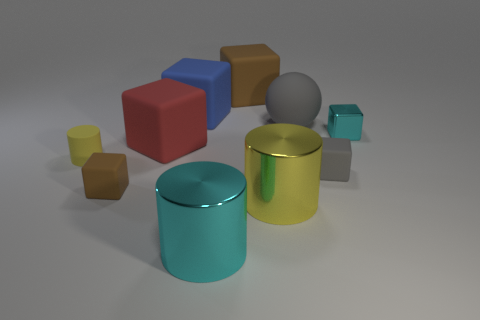There is a red rubber cube; is it the same size as the cyan object on the left side of the shiny cube?
Provide a succinct answer. Yes. What number of matte objects are either cylinders or small things?
Give a very brief answer. 3. Are there more tiny cylinders than objects?
Your answer should be compact. No. What is the size of the block that is the same color as the matte sphere?
Make the answer very short. Small. What is the shape of the cyan object in front of the brown cube in front of the large blue rubber object?
Keep it short and to the point. Cylinder. There is a small cube that is left of the cyan metallic object on the left side of the small shiny cube; is there a brown matte thing that is left of it?
Give a very brief answer. No. The ball that is the same size as the blue matte cube is what color?
Make the answer very short. Gray. What shape is the object that is both to the right of the large blue rubber object and behind the large rubber sphere?
Give a very brief answer. Cube. There is a brown matte object that is left of the large block in front of the cyan block; what size is it?
Offer a terse response. Small. What number of rubber spheres are the same color as the metal cube?
Give a very brief answer. 0. 